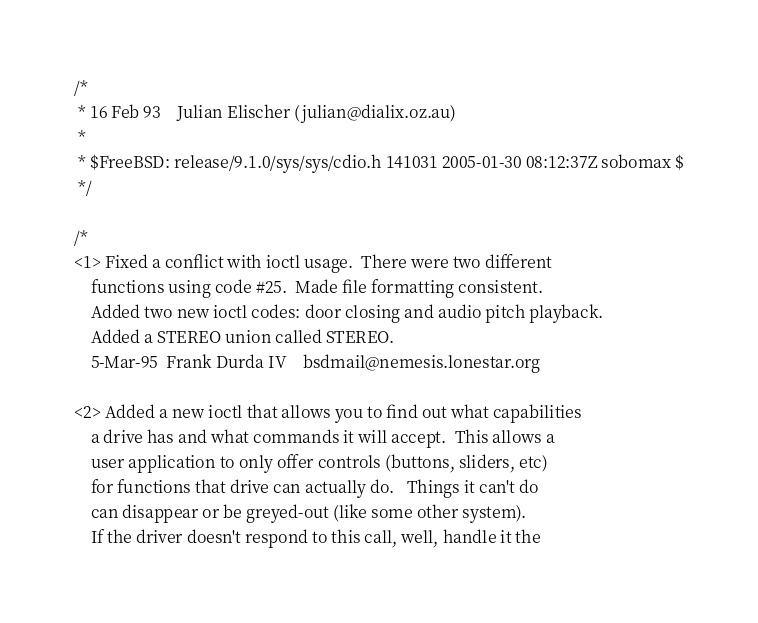Convert code to text. <code><loc_0><loc_0><loc_500><loc_500><_C_>/*
 * 16 Feb 93	Julian Elischer	(julian@dialix.oz.au)
 *
 * $FreeBSD: release/9.1.0/sys/sys/cdio.h 141031 2005-01-30 08:12:37Z sobomax $
 */

/*
<1>	Fixed a conflict with ioctl usage.  There were two different
	functions using code #25.  Made file formatting consistent.
	Added two new ioctl codes: door closing and audio pitch playback.
	Added a STEREO union called STEREO.
	5-Mar-95  Frank Durda IV	bsdmail@nemesis.lonestar.org

<2>	Added a new ioctl that allows you to find out what capabilities
	a drive has and what commands it will accept.  This allows a
	user application to only offer controls (buttons, sliders, etc)
	for functions that drive can actually do.   Things it can't do
	can disappear or be greyed-out (like some other system).
	If the driver doesn't respond to this call, well, handle it the</code> 